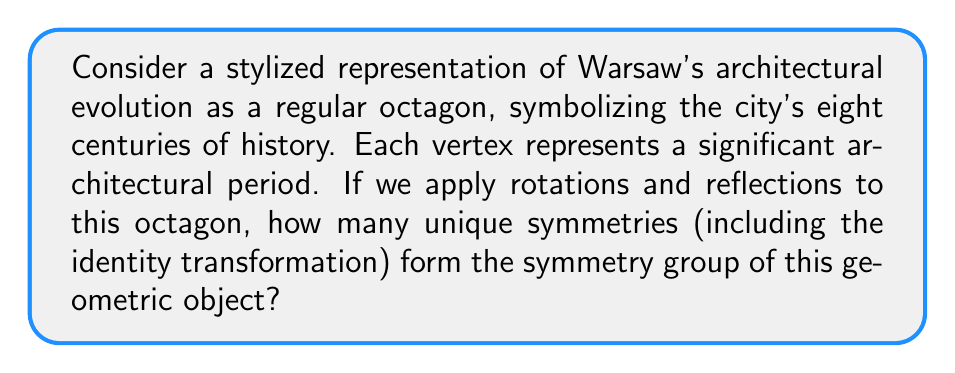Show me your answer to this math problem. Let's approach this step-by-step:

1) The symmetry group of a regular octagon is the dihedral group $D_8$.

2) To determine the number of elements in $D_8$, we need to count:
   a) Rotational symmetries
   b) Reflection symmetries

3) Rotational symmetries:
   - The octagon can be rotated by multiples of 45° (360°/8 = 45°)
   - There are 8 distinct rotations: 0°, 45°, 90°, 135°, 180°, 225°, 270°, 315°
   
4) Reflection symmetries:
   - There are 8 axes of reflection:
     - 4 passing through opposite vertices
     - 4 passing through the midpoints of opposite sides

5) Total number of symmetries:
   - 8 rotations + 8 reflections = 16 symmetries

6) The group operation is composition of transformations.

7) This group satisfies all group axioms:
   - Closure: Combining any two symmetries results in another symmetry
   - Associativity: $(a * b) * c = a * (b * c)$ for all symmetries $a$, $b$, $c$
   - Identity: The 0° rotation (identity transformation) exists
   - Inverse: Each symmetry has an inverse (e.g., a 45° rotation is undone by a 315° rotation)

Therefore, the symmetry group of the octagon representing Warsaw's architectural evolution has 16 elements.
Answer: 16 